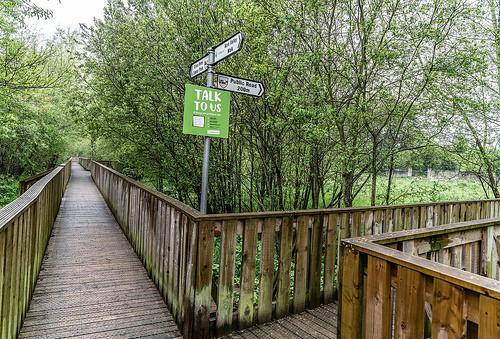<image>
Is the sky behind the board? Yes. From this viewpoint, the sky is positioned behind the board, with the board partially or fully occluding the sky. 